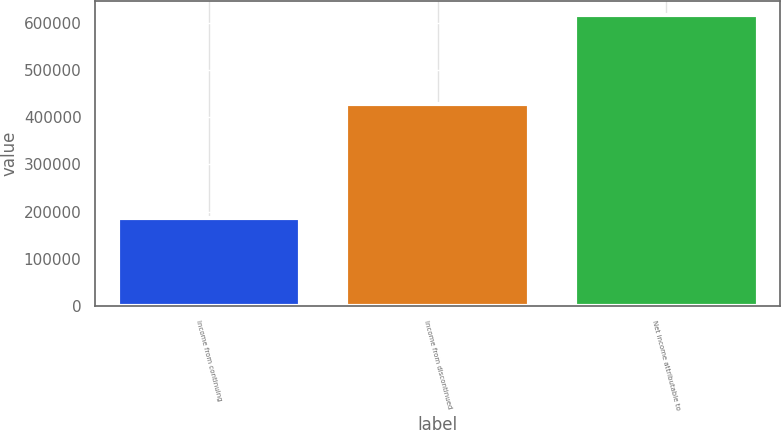Convert chart to OTSL. <chart><loc_0><loc_0><loc_500><loc_500><bar_chart><fcel>Income from continuing<fcel>Income from discontinued<fcel>Net income attributable to<nl><fcel>187099<fcel>428211<fcel>615310<nl></chart> 